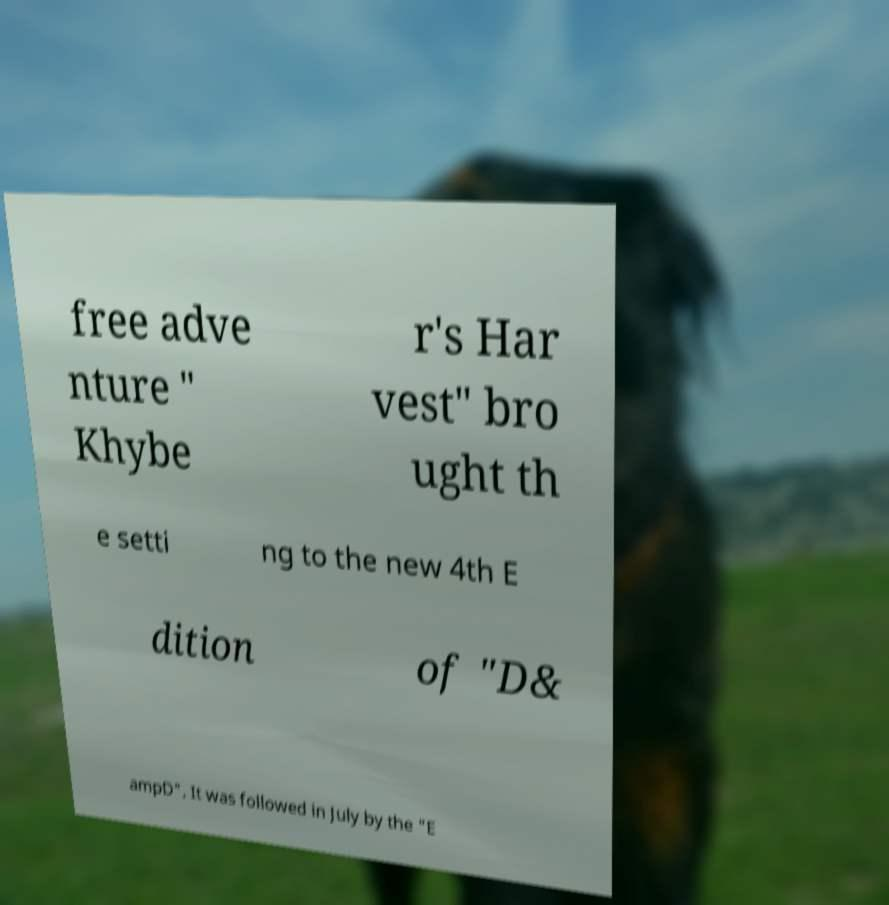Please read and relay the text visible in this image. What does it say? free adve nture " Khybe r's Har vest" bro ught th e setti ng to the new 4th E dition of "D& ampD". It was followed in July by the "E 